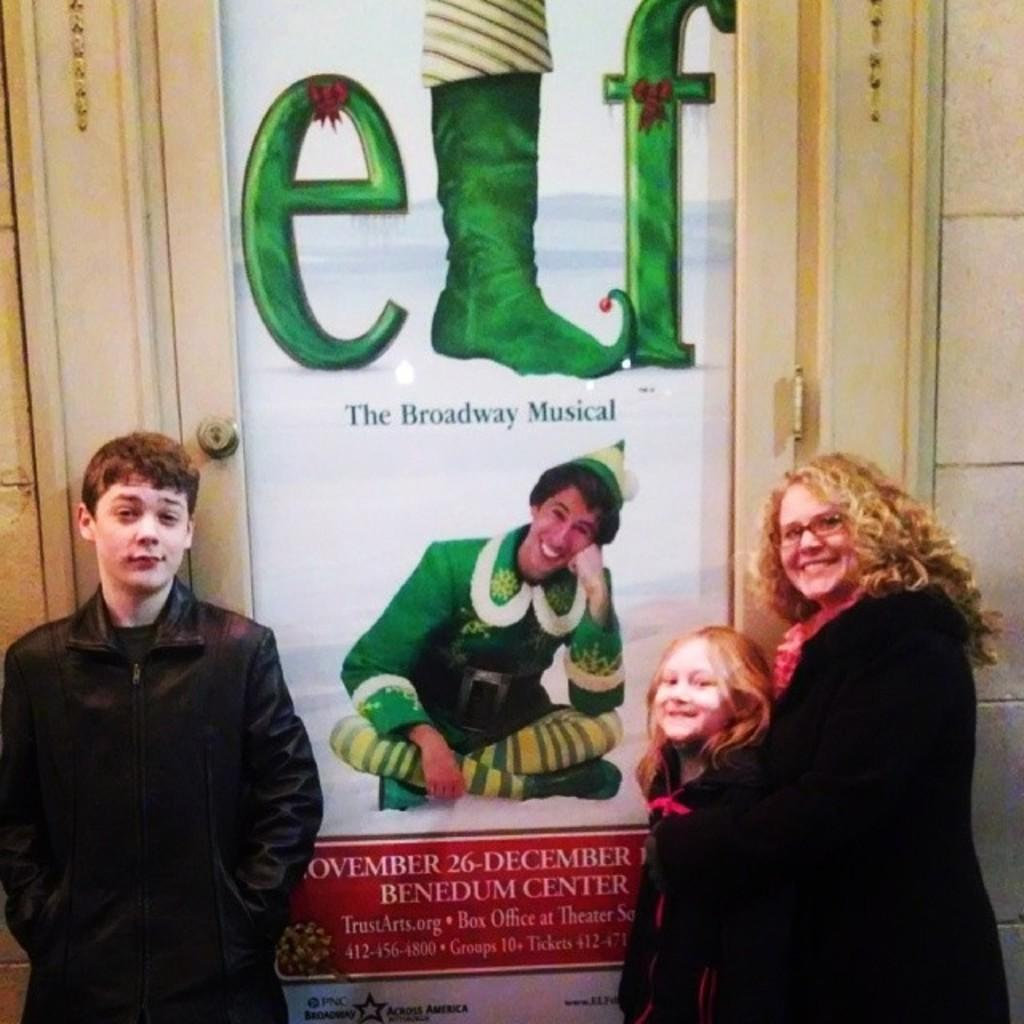What type of structure can be seen in the image? There is a wall in the image. Are there any openings in the wall? Yes, there is a door in the image. What is hanging on the wall? There is a banner in the image. How many people are present in the image? There are three people in the image. What color are the dresses worn by the people? The three people are wearing black color dresses. How many oranges are being added to the banner in the image? There are no oranges present in the image, and no addition is taking place. Can you see any cats in the image? There are no cats visible in the image. 